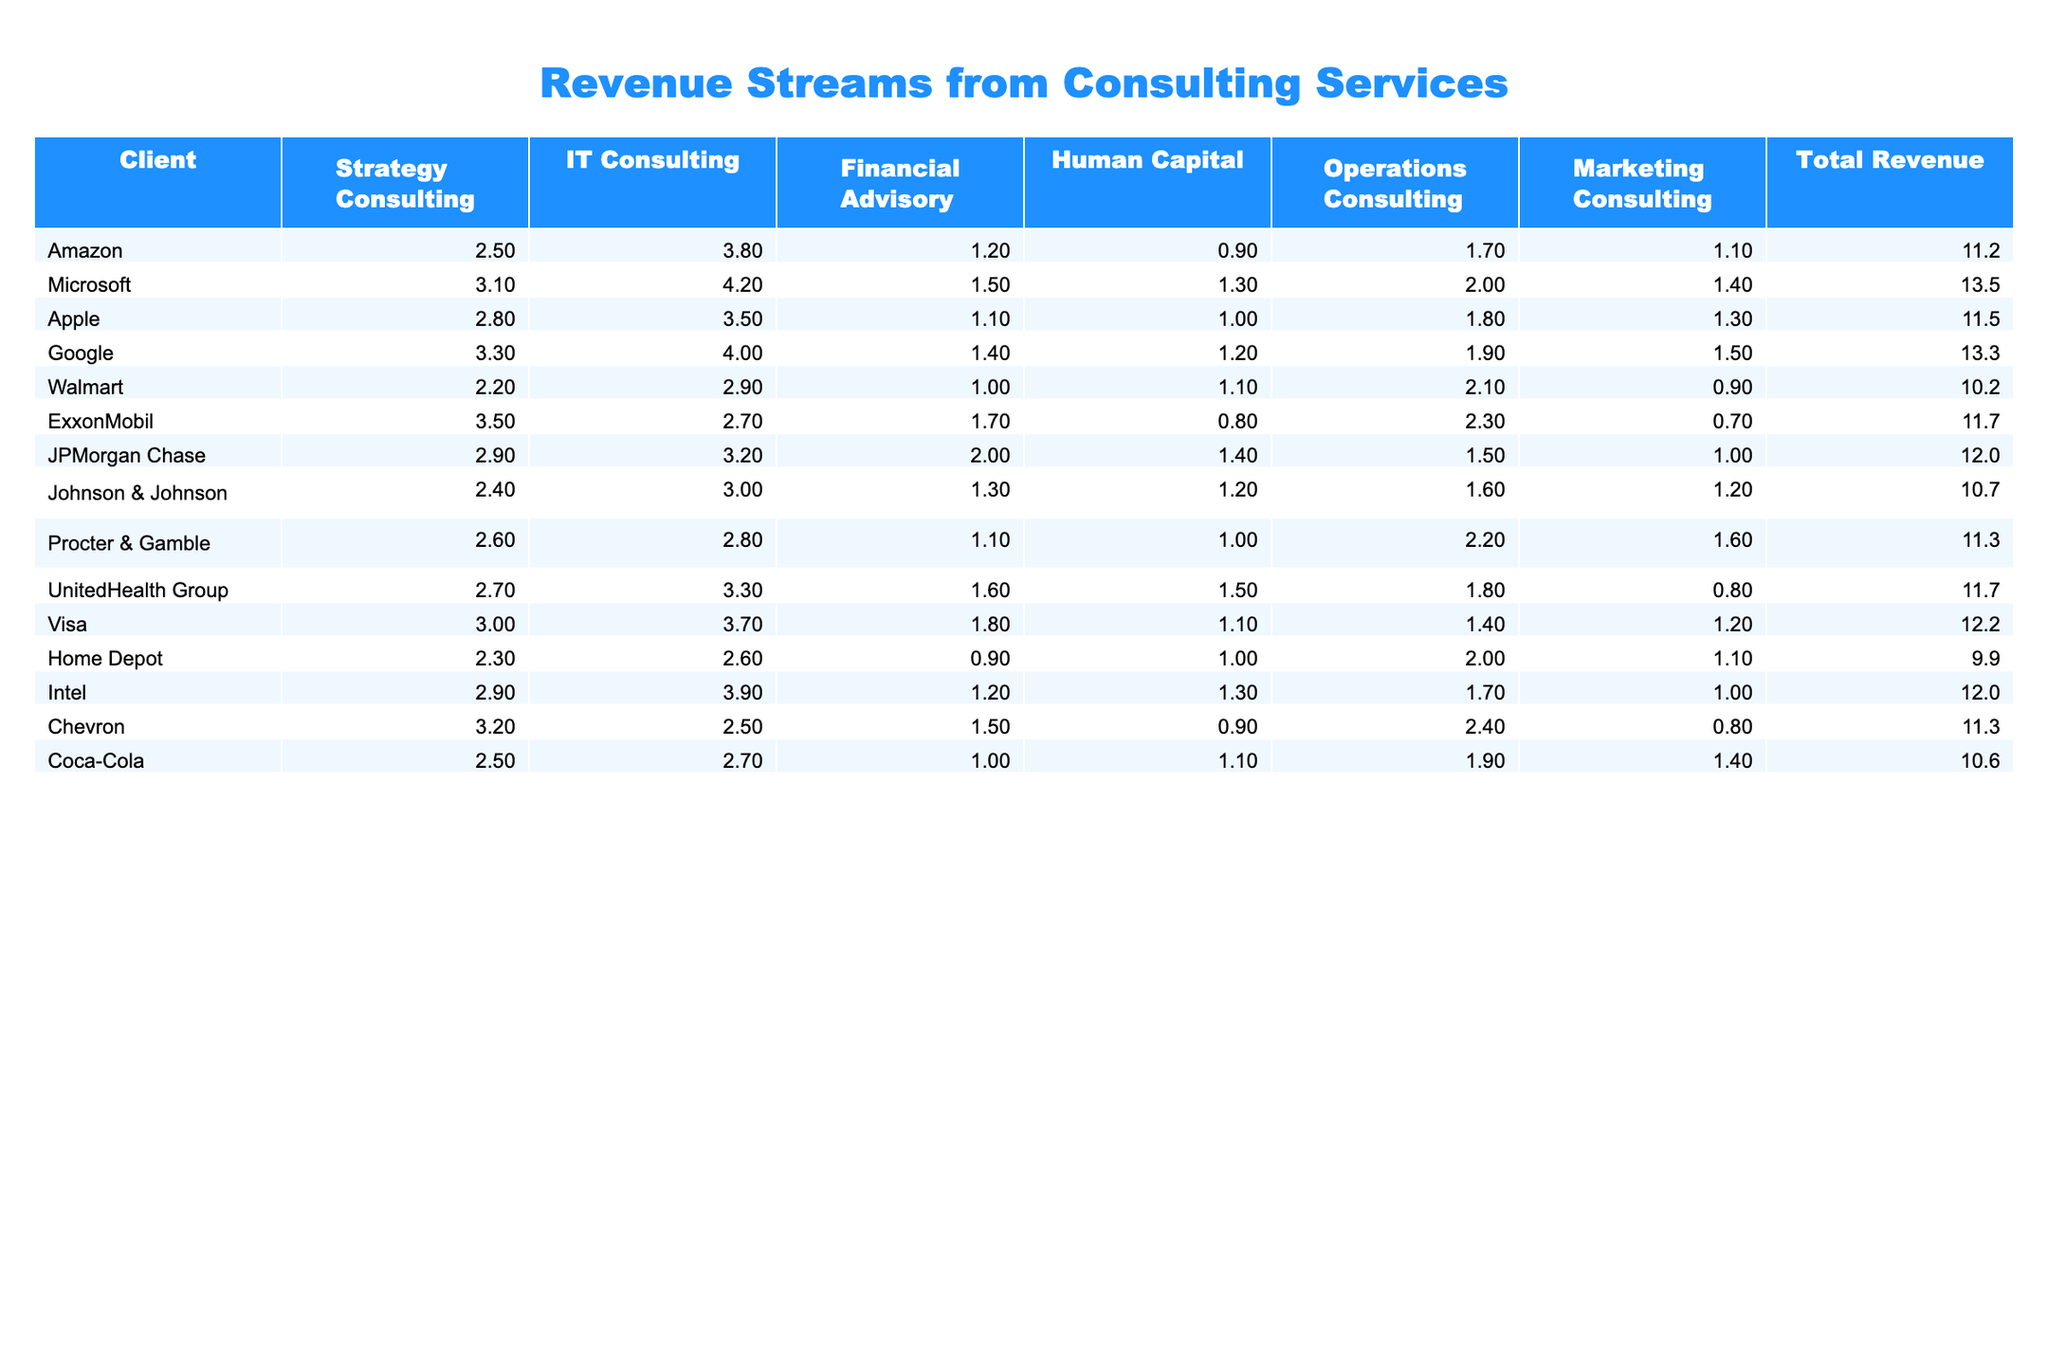What is the total revenue generated by Microsoft from consulting services? The total revenue for Microsoft is provided in the last column of the table. It states $13.5M.
Answer: $13.5M Which company earned the highest amount from IT consulting services? The IT consulting revenue for each company can be compared, and the highest value is found under the IT Consulting column for Microsoft, which earned $4.2M.
Answer: Microsoft How much more revenue did Google generate from Strategy Consulting compared to Walmart? To find the difference, subtract Walmart's revenue from Google’s in Strategy Consulting: $3.3M (Google) - $2.2M (Walmart) = $1.1M.
Answer: $1.1M What is the average revenue from Human Capital consulting services among all clients? The values for Human Capital services are: $0.9M, $1.3M, $1.0M, $1.2M, $1.0M, $1.5M, $1.2M, $1.0M, $1.5M, $1.5M. Adding these ($0.9 + 1.3 + 1.0 + 1.2 + 1.0 + 1.5 + 1.2 + 1.0 + 1.5) gives a total of $12.1M. There are 10 clients, so the average is 12.1M / 10 = $1.21M.
Answer: $1.21M Did any company have exactly $10M in total revenue from consulting services? By checking the Total Revenue column, Home Depot is listed as having $9.9M, which is less than $10M, and all other companies have values greater than $10M, indicating that there are no companies with exactly $10M.
Answer: No Which service contributed the most to Amazon's total revenue, and what was the amount? The highest single figure in Amazon's row can be found by comparing all service columns, which is $3.8M from IT Consulting services.
Answer: IT Consulting, $3.8M What percentage of total revenue does Financial Advisory represent for JPMorgan Chase? The Financial Advisory revenue of JPMorgan Chase is $2.0M, and the total revenue is $12.0M. To determine the percentage, divide $2.0M by $12.0M and then multiply by 100, resulting in (2.0 / 12.0) * 100 = 16.67%.
Answer: 16.67% If you combine the revenues from Operations Consulting of Apple and Procter & Gamble, what is the total? The Operations Consulting revenues for Apple and Procter & Gamble are $1.0M and $2.2M, respectively. Adding these together gives $1.0M + $2.2M = $3.2M.
Answer: $3.2M Which client has the lowest total revenue, and what is that amount? By reviewing the Total Revenue column, Home Depot is identified as the client with the lowest total at $9.9M.
Answer: Home Depot, $9.9M Is the total revenue from Coca-Cola greater than that of Intel? Coca-Cola has a total revenue of $10.6M, while Intel has $12.0M. Since $10.6M is less than $12.0M, the answer is no.
Answer: No 